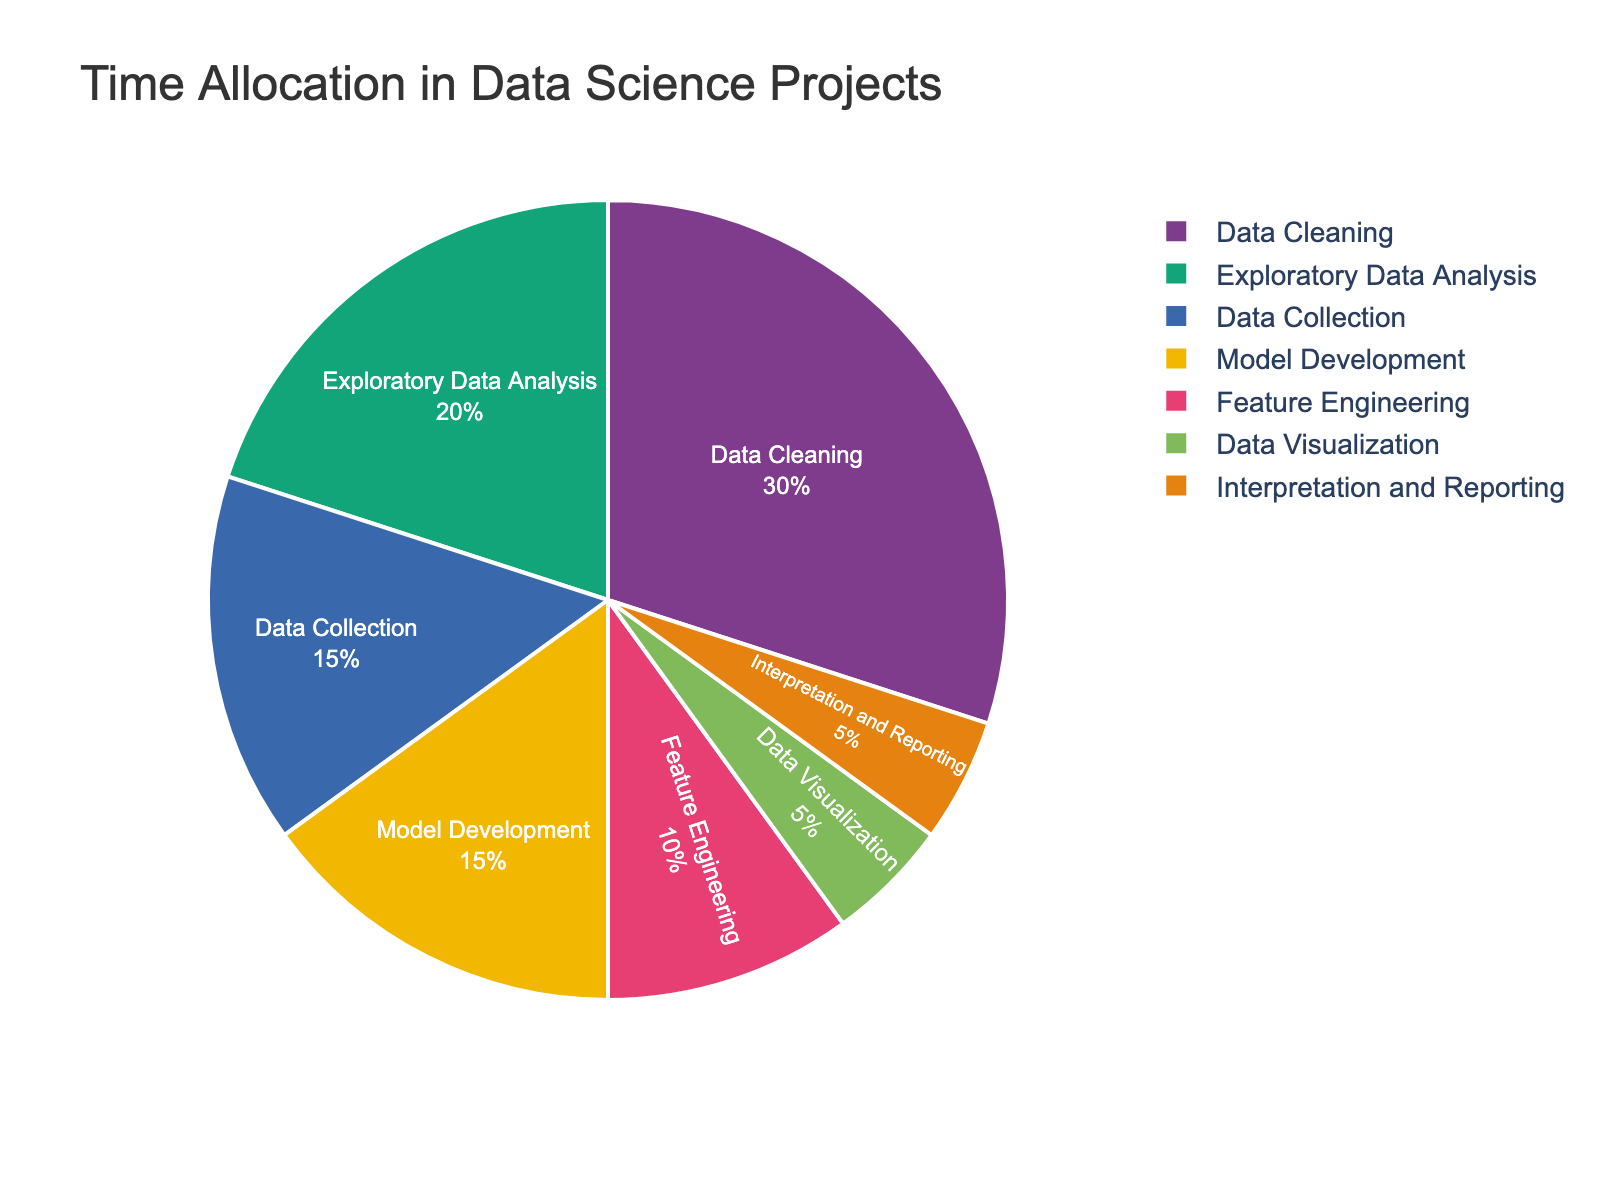What's the largest phase in terms of time allocation? The phase with the highest percentage in the pie chart represents the largest time allocation. In this case, Data Cleaning has the highest percentage.
Answer: Data Cleaning Which two phases have the same time allocation? By inspecting the pie chart, we can identify that both Model Development and Data Collection have the same percentage values.
Answer: Model Development and Data Collection What is the total percentage of time spent on Data Collection and Data Cleaning combined? First, find the percentage values for Data Collection and Data Cleaning from the pie chart, which are 15% and 30% respectively. Sum these values (15% + 30%).
Answer: 45% Which phase takes up less time than Data Visualization? From the pie chart, Data Visualization has a 5% allocation. Interpretation and Reporting also has a 5% allocation, but it is not less. There is no phase with less time than Data Visualization.
Answer: None What are the two phases that together take up 10% of the time? Since the percentages in the pie chart must sum to 10%, we look for two phases that each take up 5% of the time. These are Data Visualization and Interpretation and Reporting.
Answer: Data Visualization and Interpretation and Reporting What is the average time allocation of all phases combined? To find the average time allocation, sum all percentages (15% + 30% + 20% + 10% + 15% + 5% + 5%) to get 100%, then divide by the number of phases (7).
Answer: 14.29% What phase spends more time, Feature Engineering or Model Development? Looking at the pie chart, Model Development and Feature Engineering have 15% and 10% respectively. Thus, Model Development spends more time.
Answer: Model Development Which phase spends the least amount of time? By examining the pie chart, the phase with the smallest percentage is Data Visualization and Interpretation and Reporting, both with 5%.
Answer: Data Visualization and Interpretation and Reporting What is the combined time allocation for Exploratory Data Analysis and Model Development? The percentages for Exploratory Data Analysis and Model Development from the pie chart are 20% and 15% respectively. Sum these values (20% + 15%).
Answer: 35% What would be the percentage difference if Data Cleaning's time allocation was reduced by half? Data Cleaning is currently at 30%. If reduced by half, it becomes 15%. The difference is 30% - 15%.
Answer: 15% 